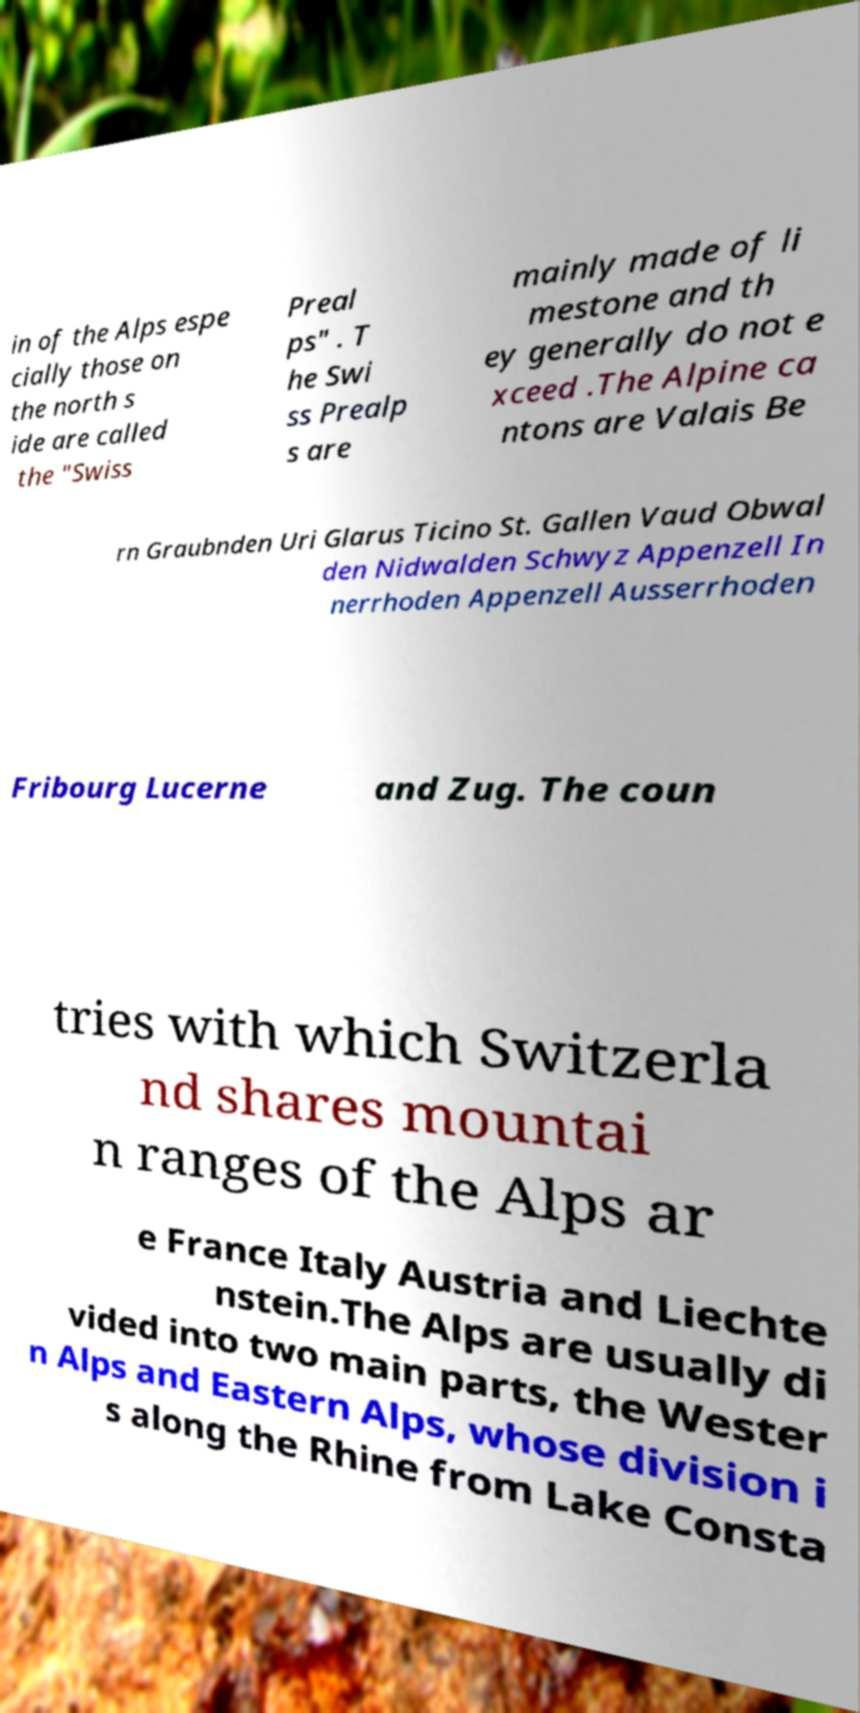Could you extract and type out the text from this image? in of the Alps espe cially those on the north s ide are called the "Swiss Preal ps" . T he Swi ss Prealp s are mainly made of li mestone and th ey generally do not e xceed .The Alpine ca ntons are Valais Be rn Graubnden Uri Glarus Ticino St. Gallen Vaud Obwal den Nidwalden Schwyz Appenzell In nerrhoden Appenzell Ausserrhoden Fribourg Lucerne and Zug. The coun tries with which Switzerla nd shares mountai n ranges of the Alps ar e France Italy Austria and Liechte nstein.The Alps are usually di vided into two main parts, the Wester n Alps and Eastern Alps, whose division i s along the Rhine from Lake Consta 